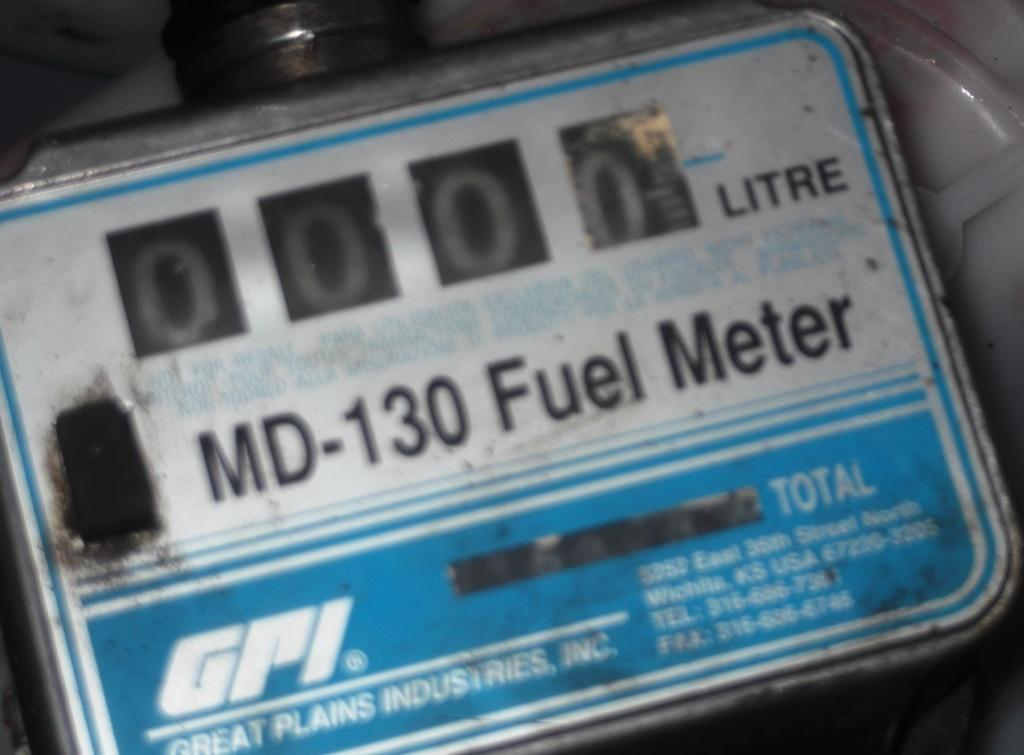What is the main object in the image that has text and numbers? There is an object with text and numbers in the image. Can you describe the other object in the background of the image? There is another object in the background of the image. How does the light change during the earthquake in the image? There is no mention of light or an earthquake in the image; it only contains an object with text and numbers and another object in the background. 